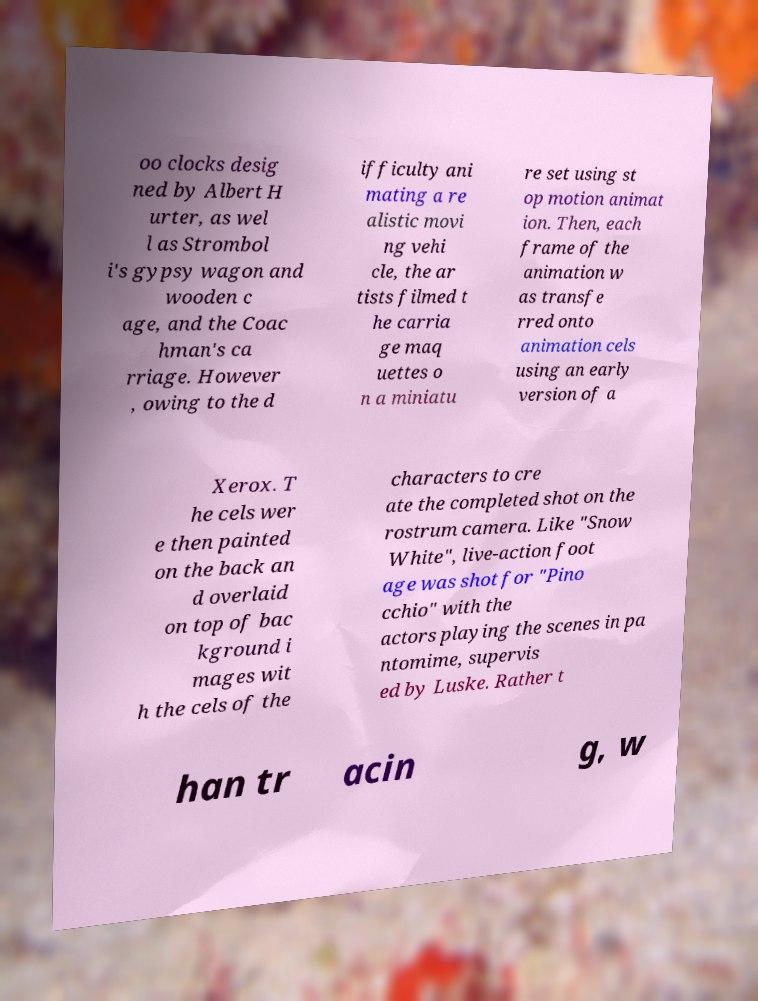There's text embedded in this image that I need extracted. Can you transcribe it verbatim? oo clocks desig ned by Albert H urter, as wel l as Strombol i's gypsy wagon and wooden c age, and the Coac hman's ca rriage. However , owing to the d ifficulty ani mating a re alistic movi ng vehi cle, the ar tists filmed t he carria ge maq uettes o n a miniatu re set using st op motion animat ion. Then, each frame of the animation w as transfe rred onto animation cels using an early version of a Xerox. T he cels wer e then painted on the back an d overlaid on top of bac kground i mages wit h the cels of the characters to cre ate the completed shot on the rostrum camera. Like "Snow White", live-action foot age was shot for "Pino cchio" with the actors playing the scenes in pa ntomime, supervis ed by Luske. Rather t han tr acin g, w 